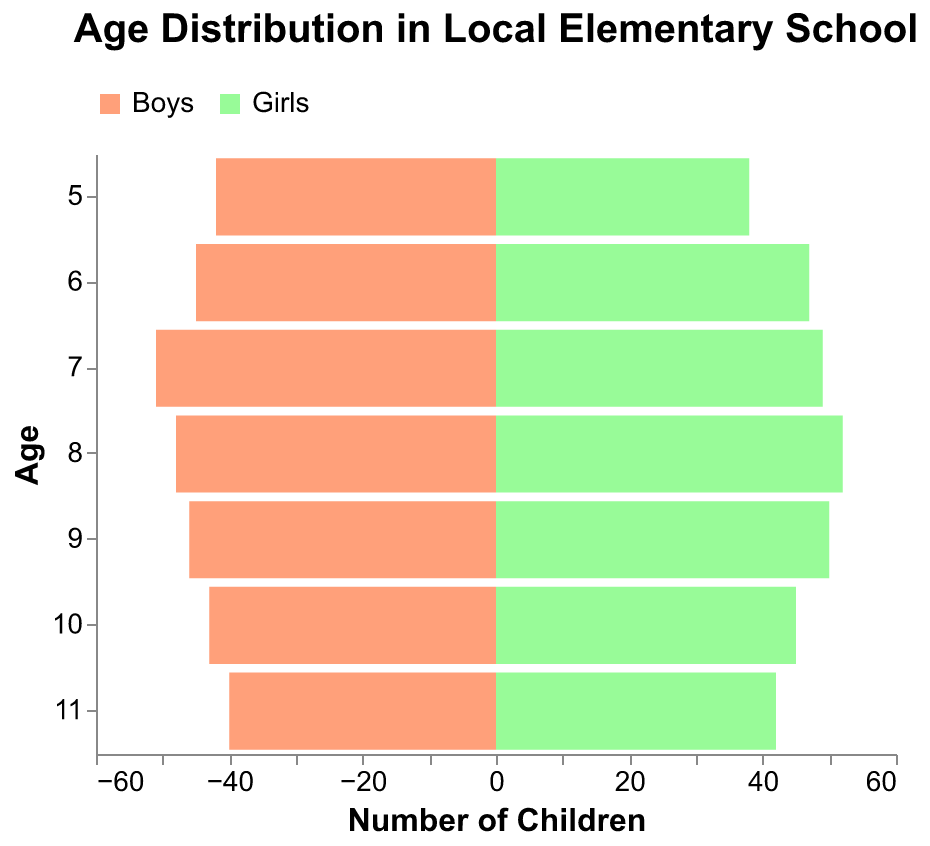What is the title of the figure? The title is written at the top of the figure, and it reads "Age Distribution in Local Elementary School".
Answer: Age Distribution in Local Elementary School How many children are there at age 5? We look at the bars corresponding to age 5 for both boys and girls, which are 42 and 38 respectively. Adding these gives us 42 + 38 = 80.
Answer: 80 Which age group has the most boys? We compare the lengths of the bars for boys across all age groups. The longest bar is for age 7 with 51 boys.
Answer: 7 Are there more girls or boys at age 8? We compare the lengths of the bars for age 8. The bar for girls is slightly longer (52) compared to the bar for boys (48).
Answer: Girls What is the total number of children age 9? We add the number of boys and girls at age 9. Boys have 46 and girls have 50, so 46 + 50 = 96.
Answer: 96 Which gender has more children overall? To find the total for each gender, add the numbers from all age groups. Boys: 42+45+51+48+46+43+40 = 315, Girls: 38+47+49+52+50+45+42 = 323. Girls have more children overall.
Answer: Girls What is the average number of boys per age group? To calculate the average, sum up the number of boys and divide by the number of age groups. The sum is 42+45+51+48+46+43+40 = 315. There are 7 age groups, so 315 / 7 = 45.
Answer: 45 At which age do boys and girls have the same number of children? We look for age groups where the lengths of the bars for boys and girls are almost equal. At age 10, boys are 43 and girls are 45 which are quite close, and at age 11 boys are 40 and girls are 42 which are also quite close.
Answer: Age 10 and Age 11 What is the difference between the number of girls and boys at age 6? Subtract the number of boys from the number of girls at age 6. Girls have 47 and boys have 45, so 47 - 45 = 2.
Answer: 2 At what age is the number of girls the highest? We compare the lengths of the bars for girls across all age groups. The longest bar for girls is at age 8 with 52 girls.
Answer: 8 